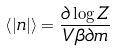Convert formula to latex. <formula><loc_0><loc_0><loc_500><loc_500>\left \langle | n | \right \rangle = \frac { \partial \log Z } { V \beta \partial m }</formula> 